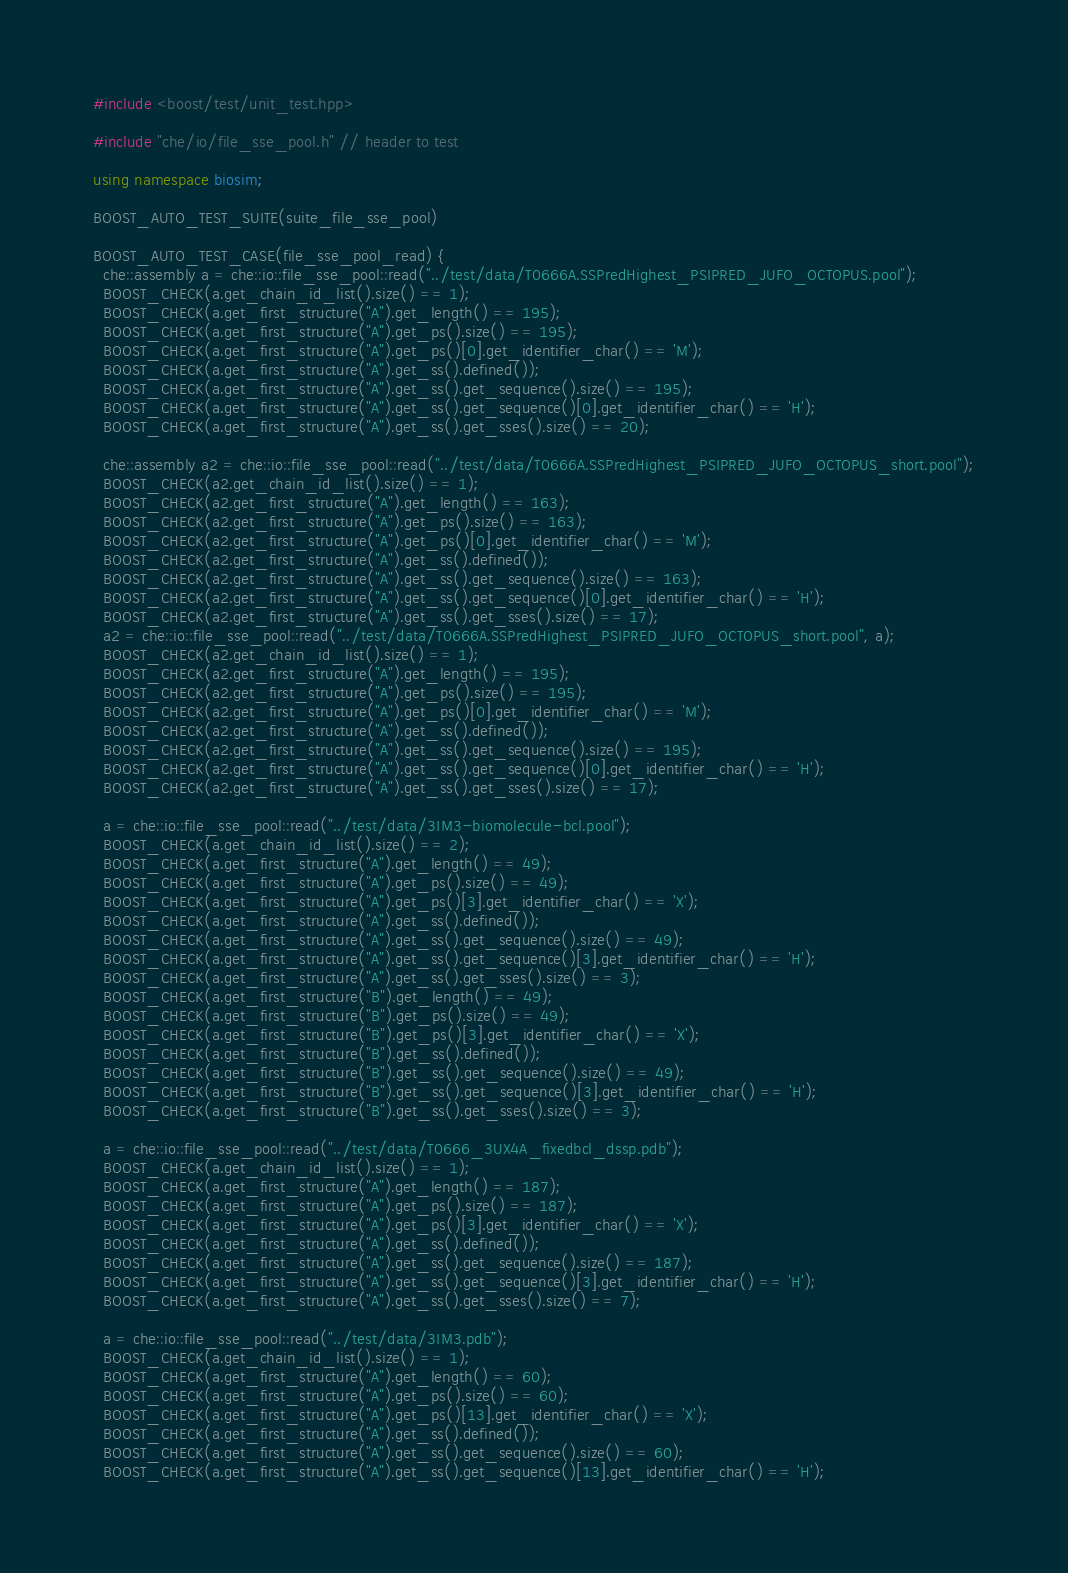<code> <loc_0><loc_0><loc_500><loc_500><_C++_>#include <boost/test/unit_test.hpp>

#include "che/io/file_sse_pool.h" // header to test

using namespace biosim;

BOOST_AUTO_TEST_SUITE(suite_file_sse_pool)

BOOST_AUTO_TEST_CASE(file_sse_pool_read) {
  che::assembly a = che::io::file_sse_pool::read("../test/data/T0666A.SSPredHighest_PSIPRED_JUFO_OCTOPUS.pool");
  BOOST_CHECK(a.get_chain_id_list().size() == 1);
  BOOST_CHECK(a.get_first_structure("A").get_length() == 195);
  BOOST_CHECK(a.get_first_structure("A").get_ps().size() == 195);
  BOOST_CHECK(a.get_first_structure("A").get_ps()[0].get_identifier_char() == 'M');
  BOOST_CHECK(a.get_first_structure("A").get_ss().defined());
  BOOST_CHECK(a.get_first_structure("A").get_ss().get_sequence().size() == 195);
  BOOST_CHECK(a.get_first_structure("A").get_ss().get_sequence()[0].get_identifier_char() == 'H');
  BOOST_CHECK(a.get_first_structure("A").get_ss().get_sses().size() == 20);

  che::assembly a2 = che::io::file_sse_pool::read("../test/data/T0666A.SSPredHighest_PSIPRED_JUFO_OCTOPUS_short.pool");
  BOOST_CHECK(a2.get_chain_id_list().size() == 1);
  BOOST_CHECK(a2.get_first_structure("A").get_length() == 163);
  BOOST_CHECK(a2.get_first_structure("A").get_ps().size() == 163);
  BOOST_CHECK(a2.get_first_structure("A").get_ps()[0].get_identifier_char() == 'M');
  BOOST_CHECK(a2.get_first_structure("A").get_ss().defined());
  BOOST_CHECK(a2.get_first_structure("A").get_ss().get_sequence().size() == 163);
  BOOST_CHECK(a2.get_first_structure("A").get_ss().get_sequence()[0].get_identifier_char() == 'H');
  BOOST_CHECK(a2.get_first_structure("A").get_ss().get_sses().size() == 17);
  a2 = che::io::file_sse_pool::read("../test/data/T0666A.SSPredHighest_PSIPRED_JUFO_OCTOPUS_short.pool", a);
  BOOST_CHECK(a2.get_chain_id_list().size() == 1);
  BOOST_CHECK(a2.get_first_structure("A").get_length() == 195);
  BOOST_CHECK(a2.get_first_structure("A").get_ps().size() == 195);
  BOOST_CHECK(a2.get_first_structure("A").get_ps()[0].get_identifier_char() == 'M');
  BOOST_CHECK(a2.get_first_structure("A").get_ss().defined());
  BOOST_CHECK(a2.get_first_structure("A").get_ss().get_sequence().size() == 195);
  BOOST_CHECK(a2.get_first_structure("A").get_ss().get_sequence()[0].get_identifier_char() == 'H');
  BOOST_CHECK(a2.get_first_structure("A").get_ss().get_sses().size() == 17);

  a = che::io::file_sse_pool::read("../test/data/3IM3-biomolecule-bcl.pool");
  BOOST_CHECK(a.get_chain_id_list().size() == 2);
  BOOST_CHECK(a.get_first_structure("A").get_length() == 49);
  BOOST_CHECK(a.get_first_structure("A").get_ps().size() == 49);
  BOOST_CHECK(a.get_first_structure("A").get_ps()[3].get_identifier_char() == 'X');
  BOOST_CHECK(a.get_first_structure("A").get_ss().defined());
  BOOST_CHECK(a.get_first_structure("A").get_ss().get_sequence().size() == 49);
  BOOST_CHECK(a.get_first_structure("A").get_ss().get_sequence()[3].get_identifier_char() == 'H');
  BOOST_CHECK(a.get_first_structure("A").get_ss().get_sses().size() == 3);
  BOOST_CHECK(a.get_first_structure("B").get_length() == 49);
  BOOST_CHECK(a.get_first_structure("B").get_ps().size() == 49);
  BOOST_CHECK(a.get_first_structure("B").get_ps()[3].get_identifier_char() == 'X');
  BOOST_CHECK(a.get_first_structure("B").get_ss().defined());
  BOOST_CHECK(a.get_first_structure("B").get_ss().get_sequence().size() == 49);
  BOOST_CHECK(a.get_first_structure("B").get_ss().get_sequence()[3].get_identifier_char() == 'H');
  BOOST_CHECK(a.get_first_structure("B").get_ss().get_sses().size() == 3);

  a = che::io::file_sse_pool::read("../test/data/T0666_3UX4A_fixedbcl_dssp.pdb");
  BOOST_CHECK(a.get_chain_id_list().size() == 1);
  BOOST_CHECK(a.get_first_structure("A").get_length() == 187);
  BOOST_CHECK(a.get_first_structure("A").get_ps().size() == 187);
  BOOST_CHECK(a.get_first_structure("A").get_ps()[3].get_identifier_char() == 'X');
  BOOST_CHECK(a.get_first_structure("A").get_ss().defined());
  BOOST_CHECK(a.get_first_structure("A").get_ss().get_sequence().size() == 187);
  BOOST_CHECK(a.get_first_structure("A").get_ss().get_sequence()[3].get_identifier_char() == 'H');
  BOOST_CHECK(a.get_first_structure("A").get_ss().get_sses().size() == 7);

  a = che::io::file_sse_pool::read("../test/data/3IM3.pdb");
  BOOST_CHECK(a.get_chain_id_list().size() == 1);
  BOOST_CHECK(a.get_first_structure("A").get_length() == 60);
  BOOST_CHECK(a.get_first_structure("A").get_ps().size() == 60);
  BOOST_CHECK(a.get_first_structure("A").get_ps()[13].get_identifier_char() == 'X');
  BOOST_CHECK(a.get_first_structure("A").get_ss().defined());
  BOOST_CHECK(a.get_first_structure("A").get_ss().get_sequence().size() == 60);
  BOOST_CHECK(a.get_first_structure("A").get_ss().get_sequence()[13].get_identifier_char() == 'H');</code> 